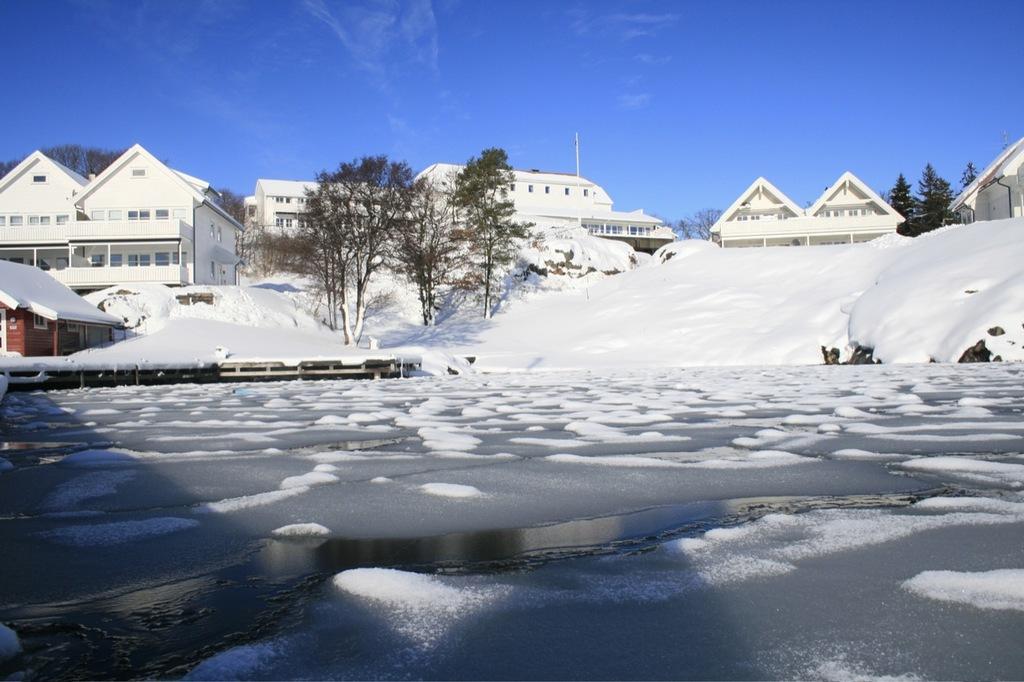How would you summarize this image in a sentence or two? At the bottom of the image there is water with ice on it. Behind the water on the ground there is snow and also there are trees. In the background there are houses. At the top of the image there is sky. 